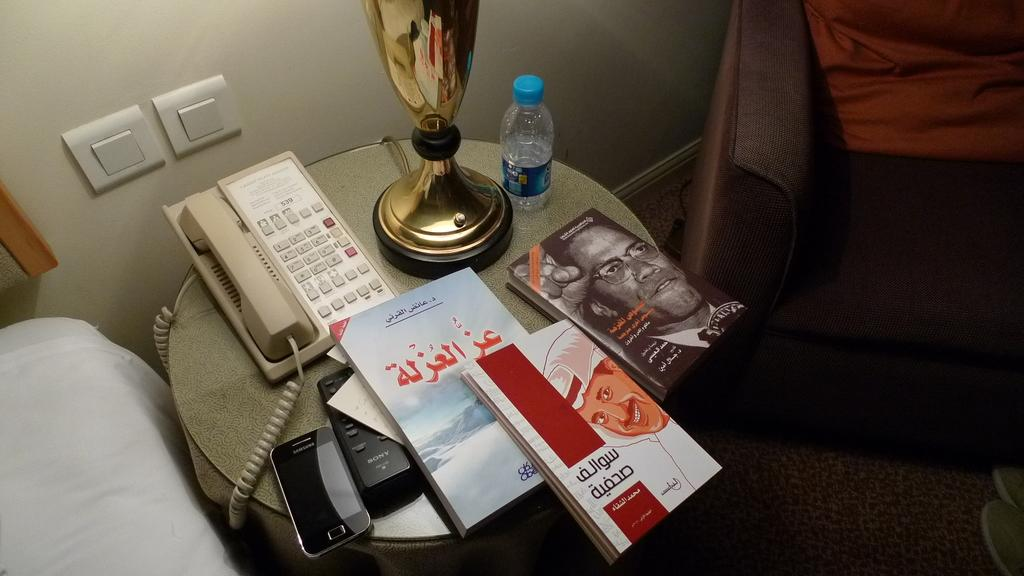<image>
Summarize the visual content of the image. books on a nightstand next to a telephone with numbers 1-0 on them 